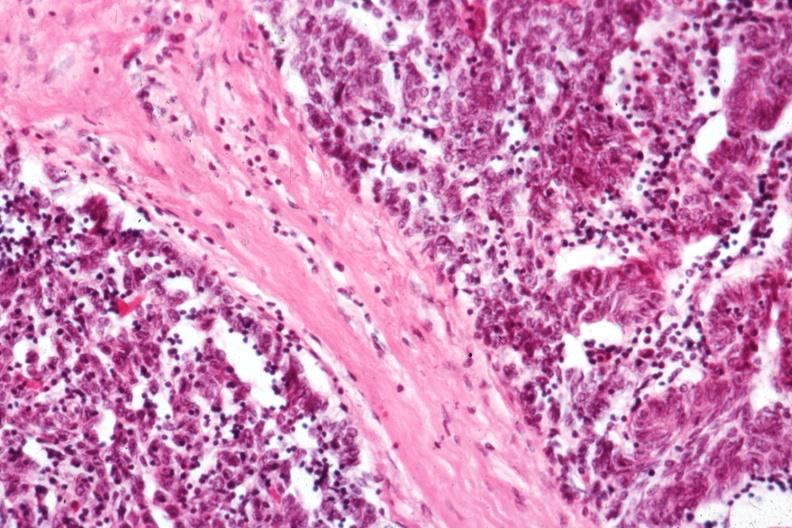what is present?
Answer the question using a single word or phrase. Thymus 